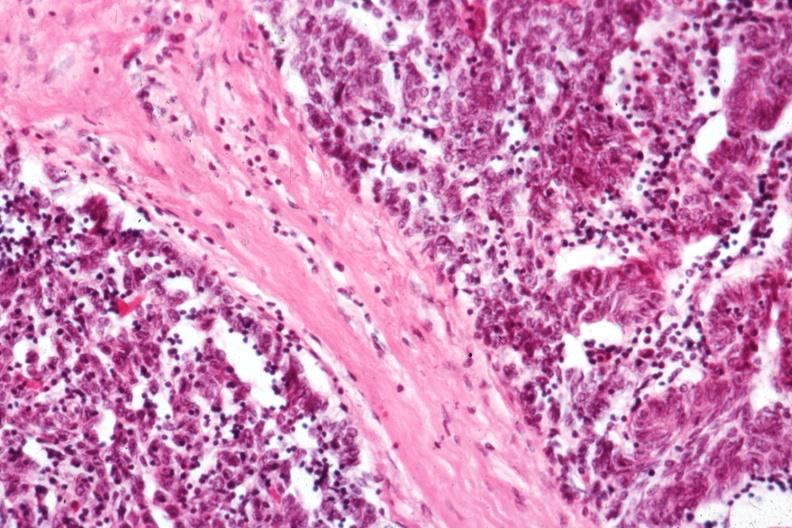what is present?
Answer the question using a single word or phrase. Thymus 